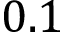<formula> <loc_0><loc_0><loc_500><loc_500>0 . 1</formula> 